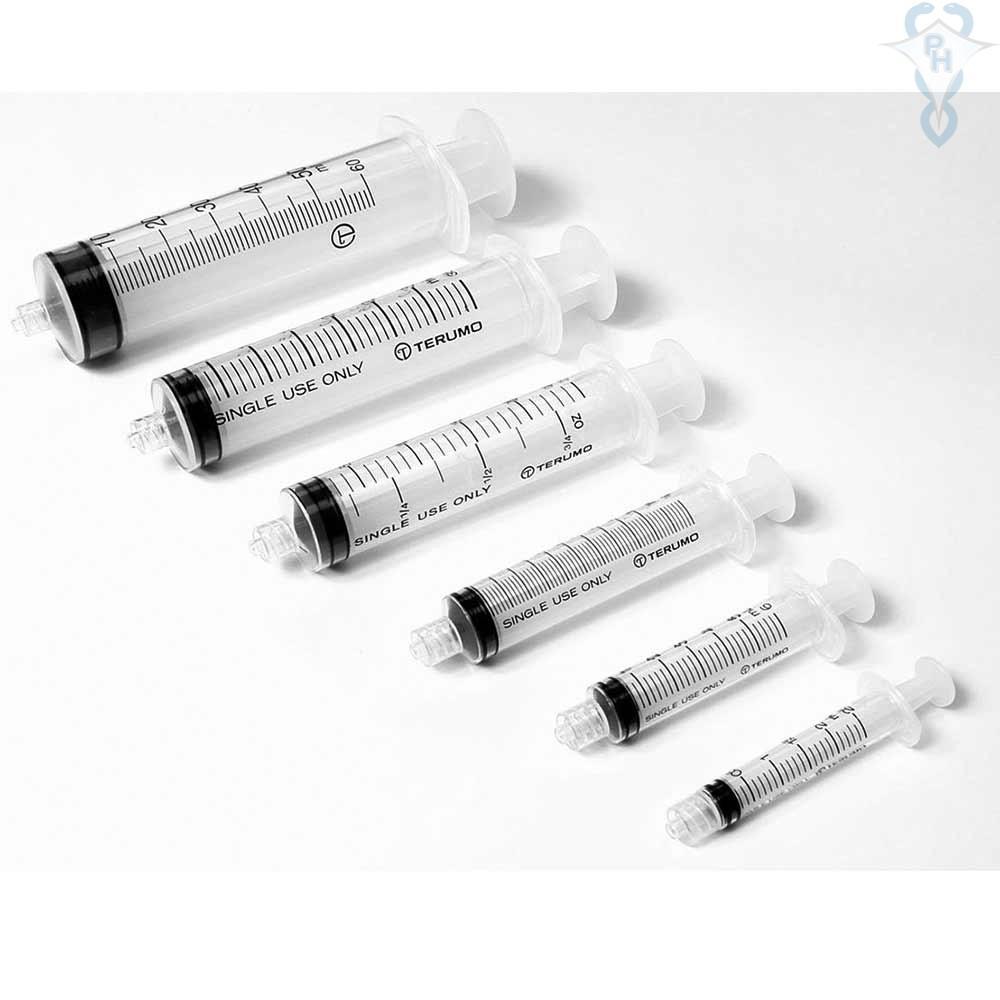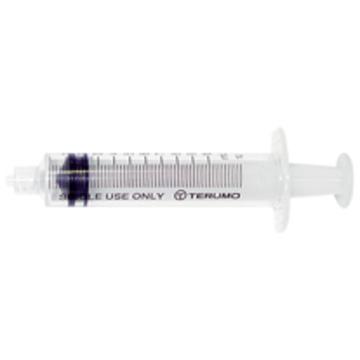The first image is the image on the left, the second image is the image on the right. Given the left and right images, does the statement "The left image has at least six syringes" hold true? Answer yes or no. Yes. The first image is the image on the left, the second image is the image on the right. For the images displayed, is the sentence "The right image shows a single syringe angled with its tip at the lower right." factually correct? Answer yes or no. No. 